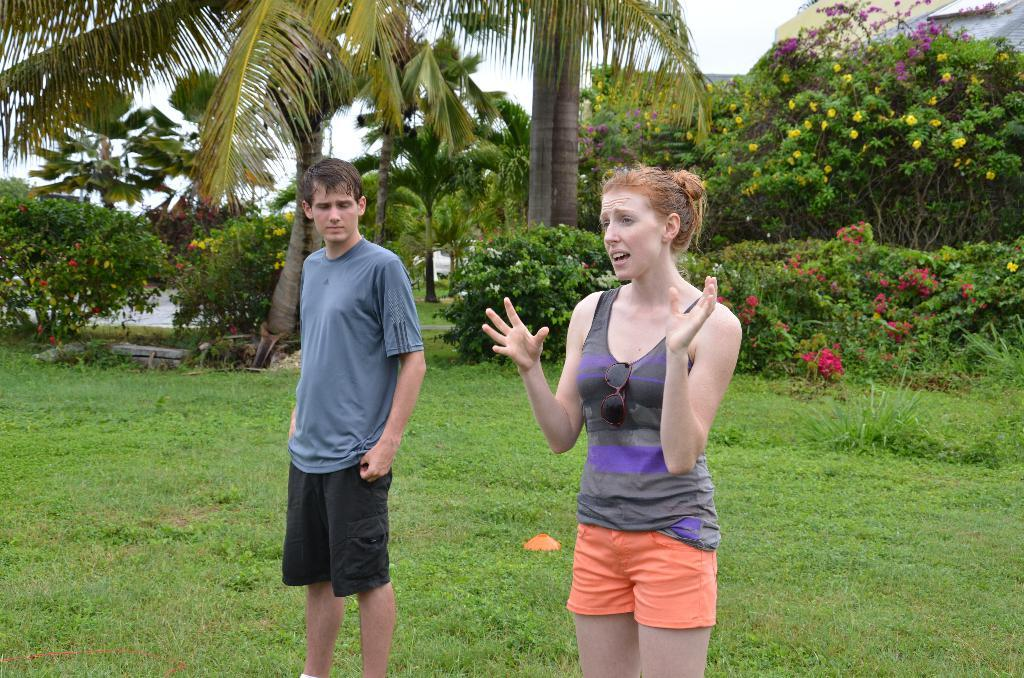How many people are in the image? There is a man and a woman in the image. What are the man and woman standing on? They are standing on the grass. What type of vegetation can be seen in the image? There are flowers and trees visible in the image. What else can be seen in the image besides the people and vegetation? There are some unspecified objects in the image. What is visible in the background of the image? The sky is visible in the background of the image. How much grain is present in the image? There is no grain present in the image. What is the level of noise in the image? The level of noise cannot be determined from the image, as it is a still photograph. 